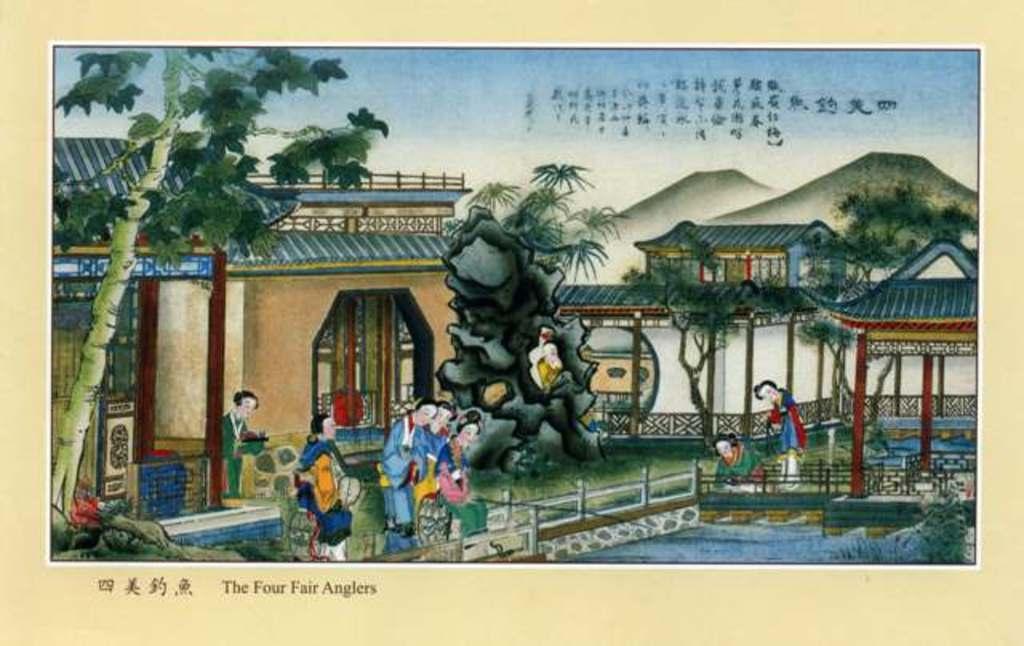Could you give a brief overview of what you see in this image? In the center of the image we can see one poster. On the poster, we can see some painting, in which we can see the sky, clouds, buildings, trees, poles, fences, hills, water, few people are standing and a few other objects. And we can see some text on the poster. And we can see the cream colored border around the image. 